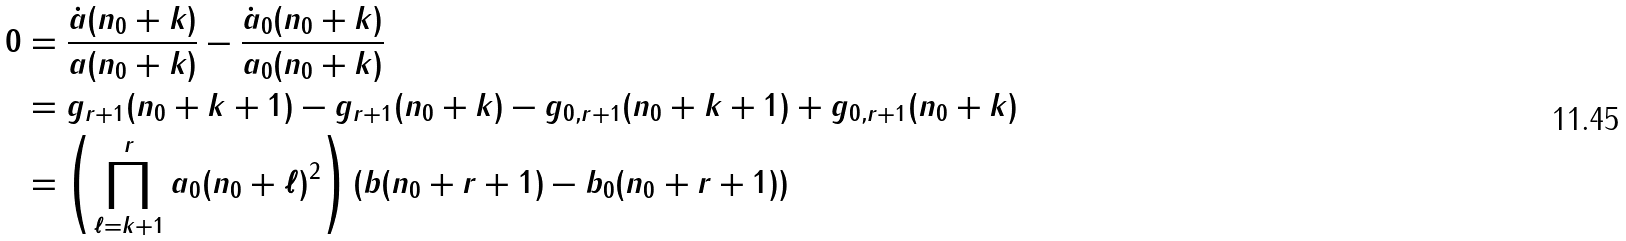Convert formula to latex. <formula><loc_0><loc_0><loc_500><loc_500>0 & = \frac { \dot { a } ( n _ { 0 } + k ) } { a ( n _ { 0 } + k ) } - \frac { \dot { a } _ { 0 } ( n _ { 0 } + k ) } { a _ { 0 } ( n _ { 0 } + k ) } \\ & = g _ { r + 1 } ( n _ { 0 } + k + 1 ) - g _ { r + 1 } ( n _ { 0 } + k ) - g _ { 0 , r + 1 } ( n _ { 0 } + k + 1 ) + g _ { 0 , r + 1 } ( n _ { 0 } + k ) \\ & = \left ( \prod _ { \ell = k + 1 } ^ { r } a _ { 0 } ( n _ { 0 } + \ell ) ^ { 2 } \right ) \left ( b ( n _ { 0 } + r + 1 ) - b _ { 0 } ( n _ { 0 } + r + 1 ) \right )</formula> 